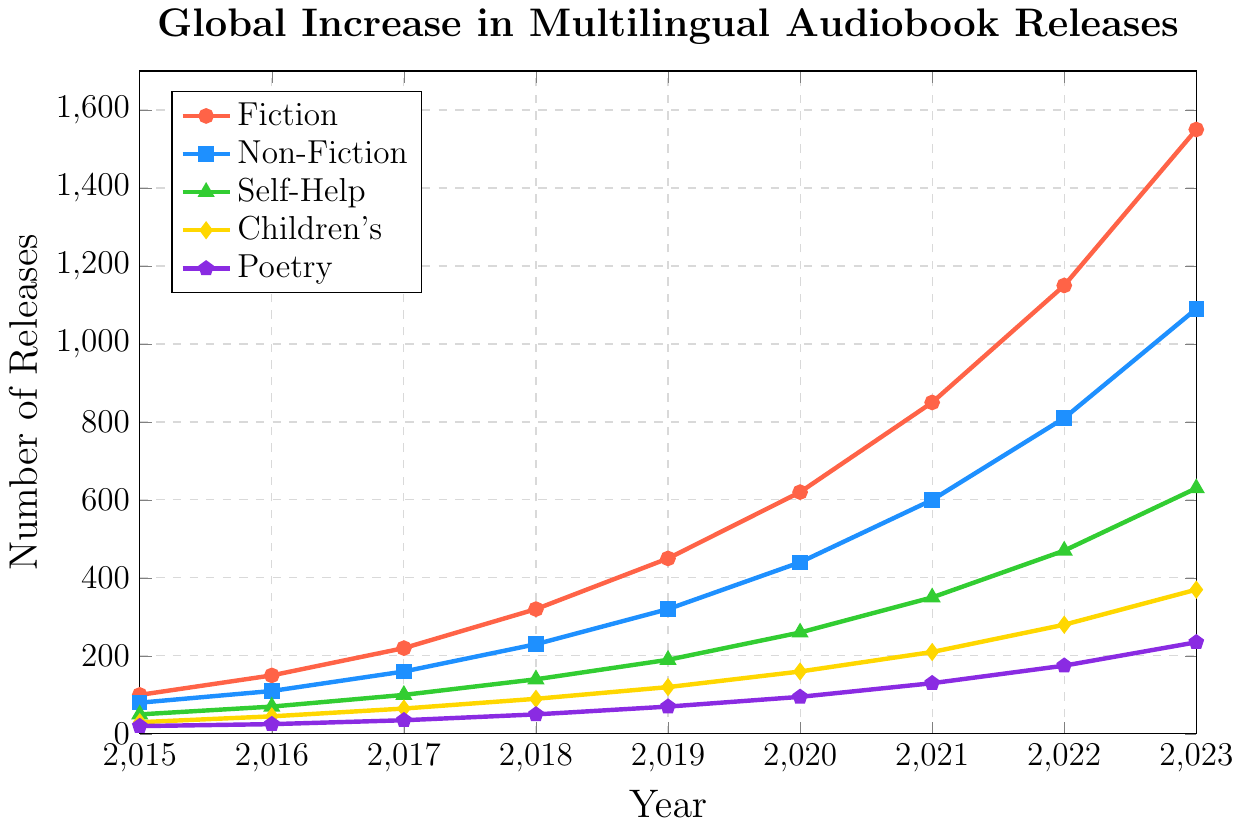What's the total number of Fiction audiobook releases across all years? Sum the Fiction audiobook releases for all the years listed: 100 + 150 + 220 + 320 + 450 + 620 + 850 + 1150 + 1550
Answer: 5410 In which year was the increase in Poetry audiobook releases the highest compared to the previous year? Identify the year-to-year increases in Poetry releases: 
2016: 25 - 20 = 5,
2017: 35 - 25 = 10,
2018: 50 - 35 = 15,
2019: 70 - 50 = 20,
2020: 95 - 70 = 25,
2021: 130 - 95 = 35,
2022: 175 - 130 = 45,
2023: 235 - 175 = 60.
Among these, the highest increase was from 2022 to 2023
Answer: 2023 By how much did the total number of Non-Fiction audiobook releases increase from 2015 to 2023? The number of Non-Fiction releases in 2015 was 80, and in 2023 it was 1090. The increase is 1090 - 80
Answer: 1010 Which genre had the smallest number of releases in 2020, and how many were there? Look at the 2020 data for each genre: Fiction: 620, Non-Fiction: 440, Self-Help: 260, Children's: 160, Poetry: 95. The smallest number was in Poetry
Answer: Poetry, 95 Compare the number of Self-Help audiobook releases in 2018 to Children's audiobook releases in 2019. Which is greater and by how much? Self-Help releases in 2018: 140, Children's releases in 2019: 120. Self-Help releases are greater by 140 - 120
Answer: Self-Help, 20 What was the average annual increase in Fiction audiobook releases from 2015 to 2023? Calculating the total increase over the period: 1550 (2023) - 100 (2015) = 1450. There are 8 intervals between the 9 years (2023 - 2015). So, the average annual increase is 1450 / 8
Answer: 181.25 Which genre showed the second most significant increase in the number of releases from 2017 to 2023? Calculate the increase for each genre from 2017 to 2023: Fiction: 1550 - 220 = 1330, Non-Fiction: 1090 - 160 = 930, Self-Help: 630 - 100 = 530, Children's: 370 - 65 = 305, Poetry: 235 - 35 = 200. The second most significant increase is in Non-Fiction
Answer: Non-Fiction Between 2016 and 2020, how many more Fiction audiobooks were released compared to Non-Fiction audiobooks? Summing the number of releases from 2016 to 2020:
Fiction: 150 + 220 + 320 + 450 + 620 = 1760,
Non-Fiction: 110 + 160 + 230 + 320 + 440 = 1260.
Difference: 1760 - 1260
Answer: 500 